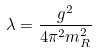Convert formula to latex. <formula><loc_0><loc_0><loc_500><loc_500>\lambda = \frac { g ^ { 2 } } { 4 \pi ^ { 2 } m ^ { 2 } _ { R } }</formula> 